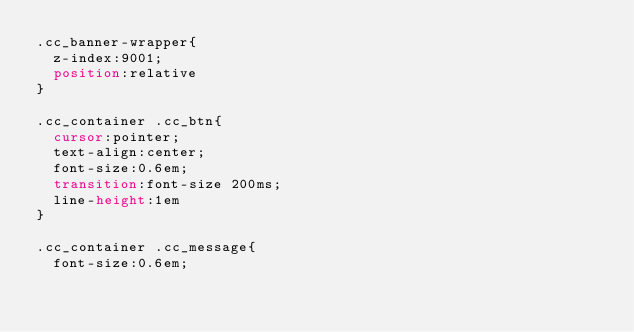<code> <loc_0><loc_0><loc_500><loc_500><_CSS_>.cc_banner-wrapper{
	z-index:9001;
	position:relative
}

.cc_container .cc_btn{
	cursor:pointer;
	text-align:center;
	font-size:0.6em;
	transition:font-size 200ms;
	line-height:1em
}

.cc_container .cc_message{
	font-size:0.6em;</code> 